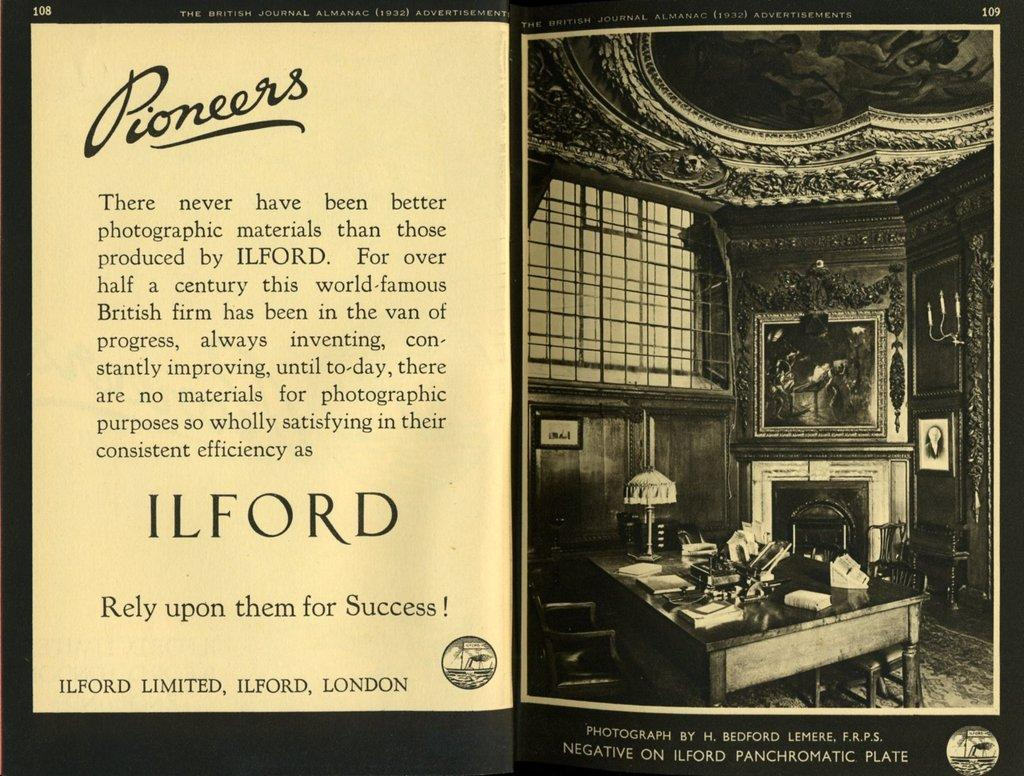<image>
Summarize the visual content of the image. A book is open to page 108 that says Pioneers with a photo of an office. 